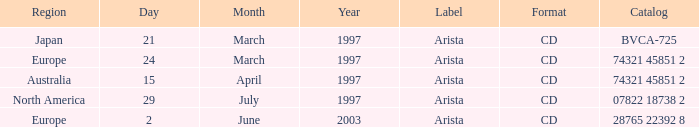What's the Date for the Region of Europe and has the Catalog of 28765 22392 8? 2 June 2003. 